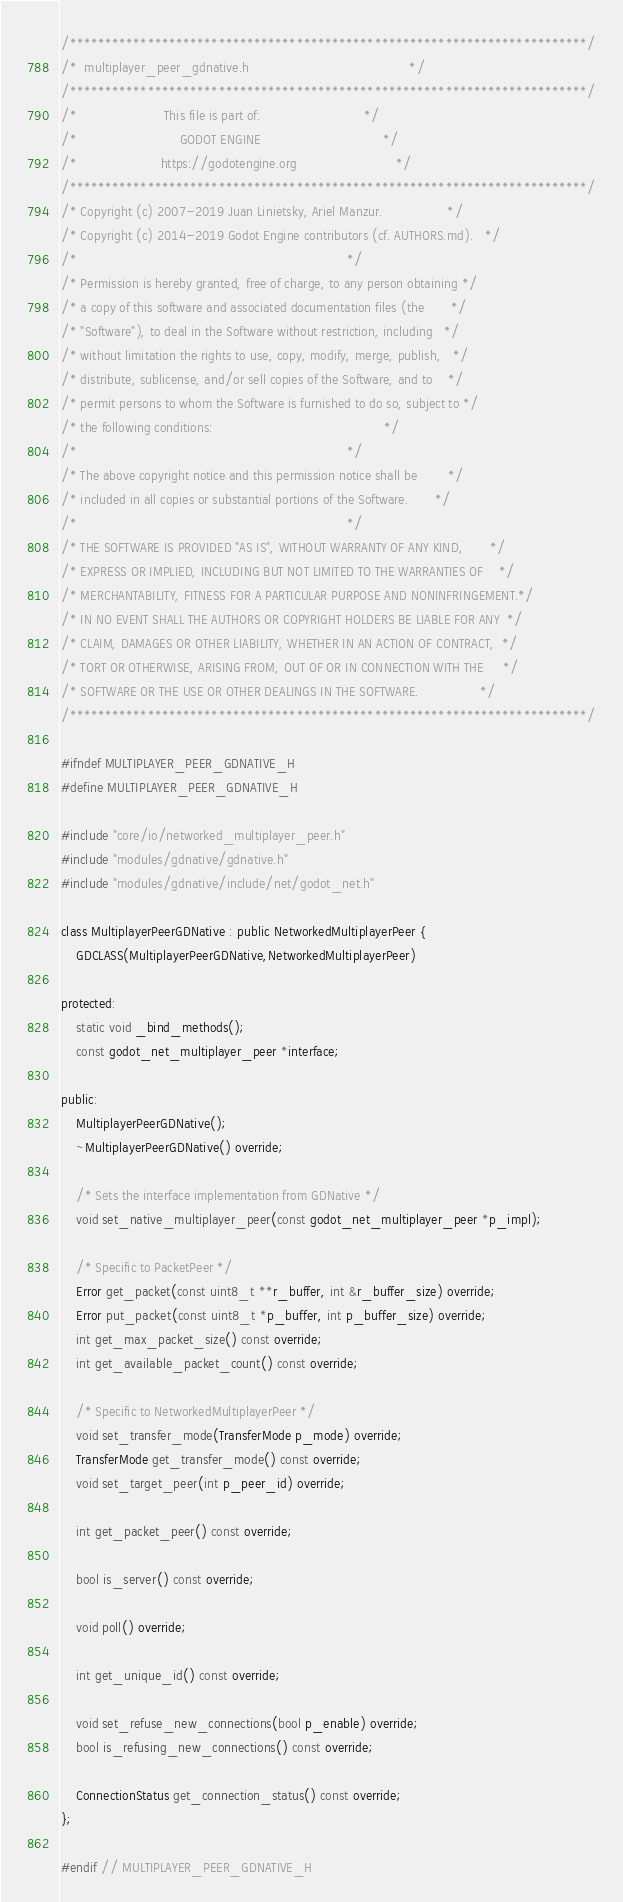<code> <loc_0><loc_0><loc_500><loc_500><_C_>/*************************************************************************/
/*  multiplayer_peer_gdnative.h                                          */
/*************************************************************************/
/*                       This file is part of:                           */
/*                           GODOT ENGINE                                */
/*                      https://godotengine.org                          */
/*************************************************************************/
/* Copyright (c) 2007-2019 Juan Linietsky, Ariel Manzur.                 */
/* Copyright (c) 2014-2019 Godot Engine contributors (cf. AUTHORS.md).   */
/*                                                                       */
/* Permission is hereby granted, free of charge, to any person obtaining */
/* a copy of this software and associated documentation files (the       */
/* "Software"), to deal in the Software without restriction, including   */
/* without limitation the rights to use, copy, modify, merge, publish,   */
/* distribute, sublicense, and/or sell copies of the Software, and to    */
/* permit persons to whom the Software is furnished to do so, subject to */
/* the following conditions:                                             */
/*                                                                       */
/* The above copyright notice and this permission notice shall be        */
/* included in all copies or substantial portions of the Software.       */
/*                                                                       */
/* THE SOFTWARE IS PROVIDED "AS IS", WITHOUT WARRANTY OF ANY KIND,       */
/* EXPRESS OR IMPLIED, INCLUDING BUT NOT LIMITED TO THE WARRANTIES OF    */
/* MERCHANTABILITY, FITNESS FOR A PARTICULAR PURPOSE AND NONINFRINGEMENT.*/
/* IN NO EVENT SHALL THE AUTHORS OR COPYRIGHT HOLDERS BE LIABLE FOR ANY  */
/* CLAIM, DAMAGES OR OTHER LIABILITY, WHETHER IN AN ACTION OF CONTRACT,  */
/* TORT OR OTHERWISE, ARISING FROM, OUT OF OR IN CONNECTION WITH THE     */
/* SOFTWARE OR THE USE OR OTHER DEALINGS IN THE SOFTWARE.                */
/*************************************************************************/

#ifndef MULTIPLAYER_PEER_GDNATIVE_H
#define MULTIPLAYER_PEER_GDNATIVE_H

#include "core/io/networked_multiplayer_peer.h"
#include "modules/gdnative/gdnative.h"
#include "modules/gdnative/include/net/godot_net.h"

class MultiplayerPeerGDNative : public NetworkedMultiplayerPeer {
	GDCLASS(MultiplayerPeerGDNative,NetworkedMultiplayerPeer)

protected:
	static void _bind_methods();
	const godot_net_multiplayer_peer *interface;

public:
	MultiplayerPeerGDNative();
	~MultiplayerPeerGDNative() override;

	/* Sets the interface implementation from GDNative */
	void set_native_multiplayer_peer(const godot_net_multiplayer_peer *p_impl);

	/* Specific to PacketPeer */
	Error get_packet(const uint8_t **r_buffer, int &r_buffer_size) override;
	Error put_packet(const uint8_t *p_buffer, int p_buffer_size) override;
	int get_max_packet_size() const override;
	int get_available_packet_count() const override;

	/* Specific to NetworkedMultiplayerPeer */
	void set_transfer_mode(TransferMode p_mode) override;
	TransferMode get_transfer_mode() const override;
	void set_target_peer(int p_peer_id) override;

	int get_packet_peer() const override;

	bool is_server() const override;

	void poll() override;

	int get_unique_id() const override;

	void set_refuse_new_connections(bool p_enable) override;
	bool is_refusing_new_connections() const override;

	ConnectionStatus get_connection_status() const override;
};

#endif // MULTIPLAYER_PEER_GDNATIVE_H
</code> 